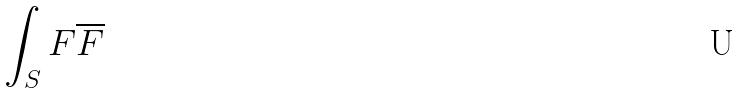Convert formula to latex. <formula><loc_0><loc_0><loc_500><loc_500>\int _ { S } F \overline { F }</formula> 